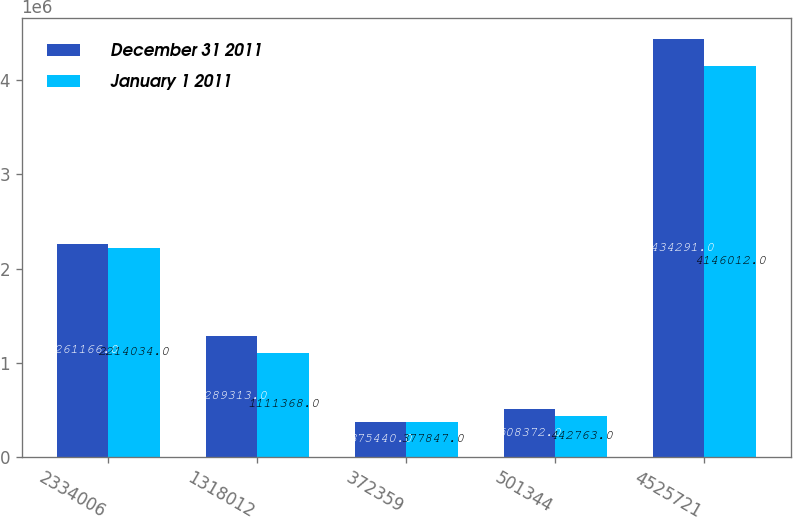Convert chart. <chart><loc_0><loc_0><loc_500><loc_500><stacked_bar_chart><ecel><fcel>2334006<fcel>1318012<fcel>372359<fcel>501344<fcel>4525721<nl><fcel>December 31 2011<fcel>2.26117e+06<fcel>1.28931e+06<fcel>375440<fcel>508372<fcel>4.43429e+06<nl><fcel>January 1 2011<fcel>2.21403e+06<fcel>1.11137e+06<fcel>377847<fcel>442763<fcel>4.14601e+06<nl></chart> 